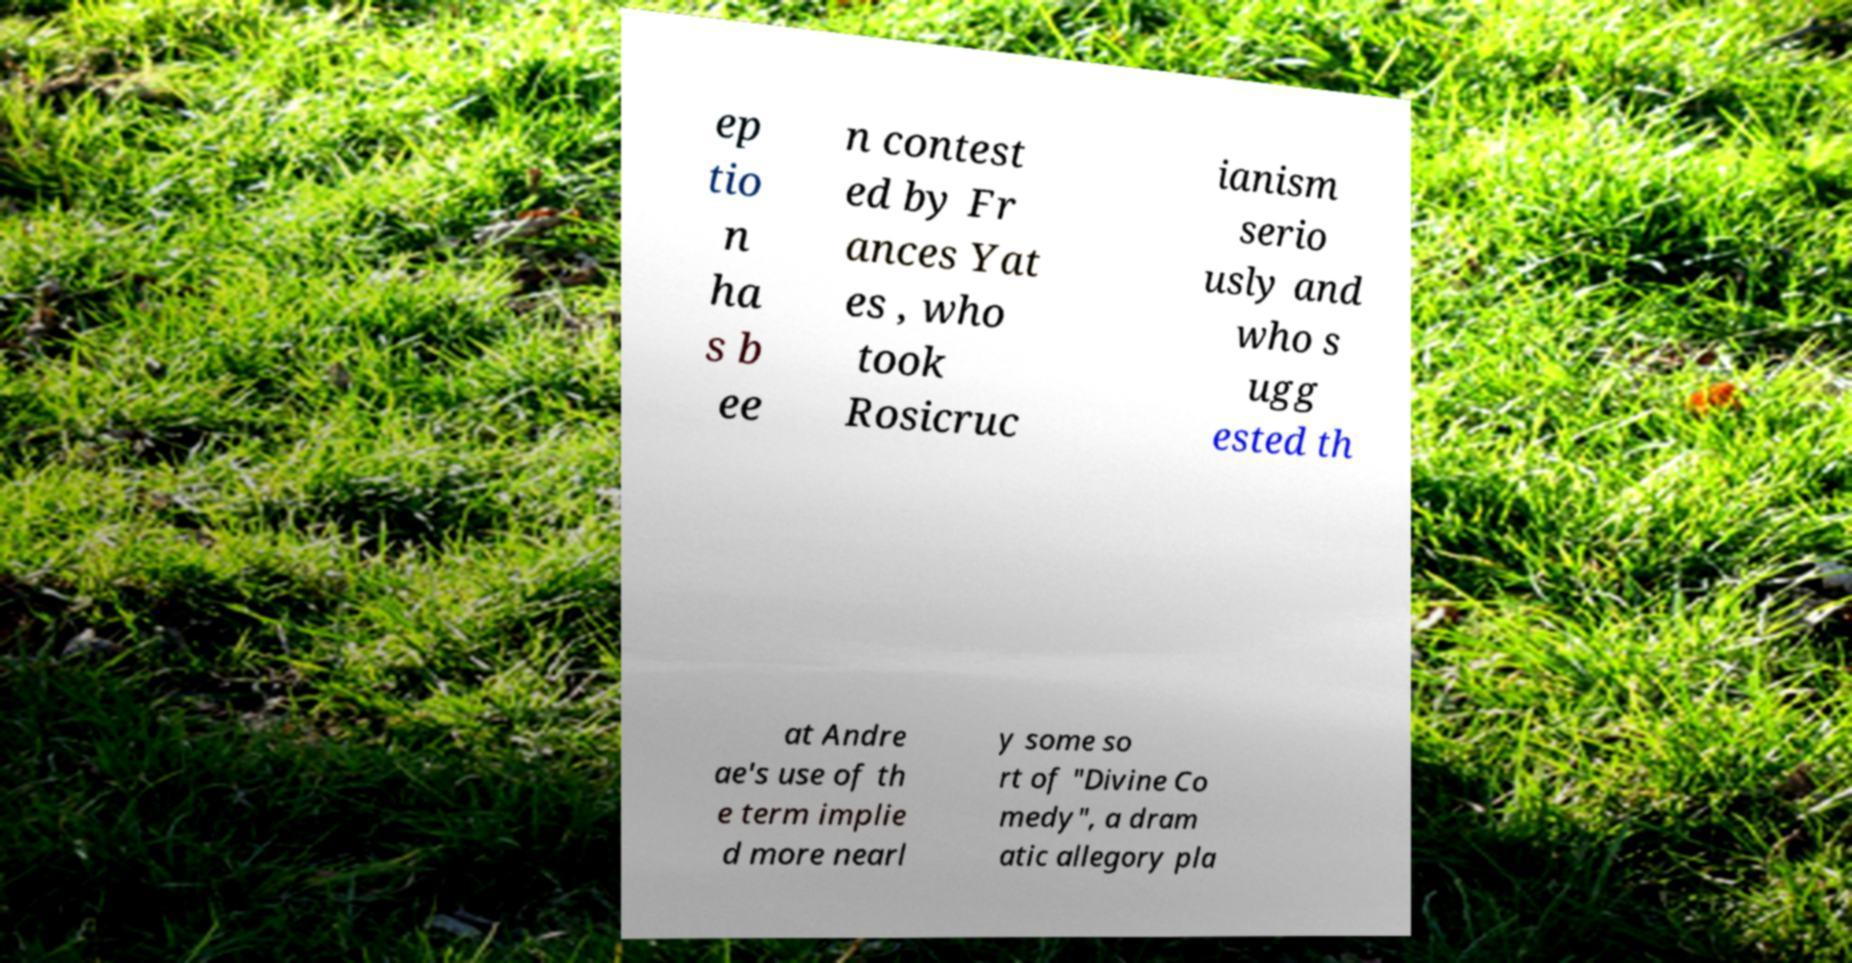Can you read and provide the text displayed in the image?This photo seems to have some interesting text. Can you extract and type it out for me? ep tio n ha s b ee n contest ed by Fr ances Yat es , who took Rosicruc ianism serio usly and who s ugg ested th at Andre ae's use of th e term implie d more nearl y some so rt of "Divine Co medy", a dram atic allegory pla 